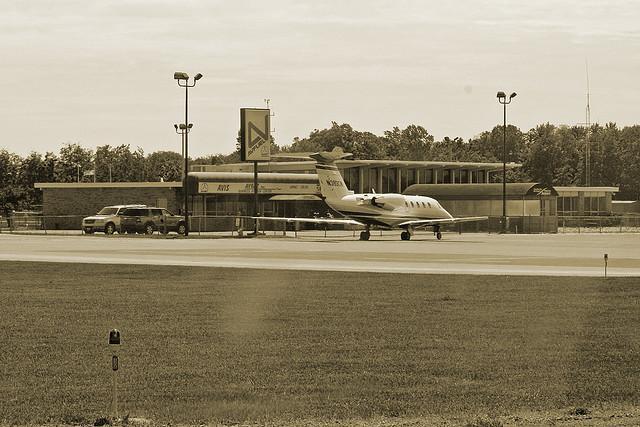How many women are wearing blue scarfs?
Give a very brief answer. 0. 